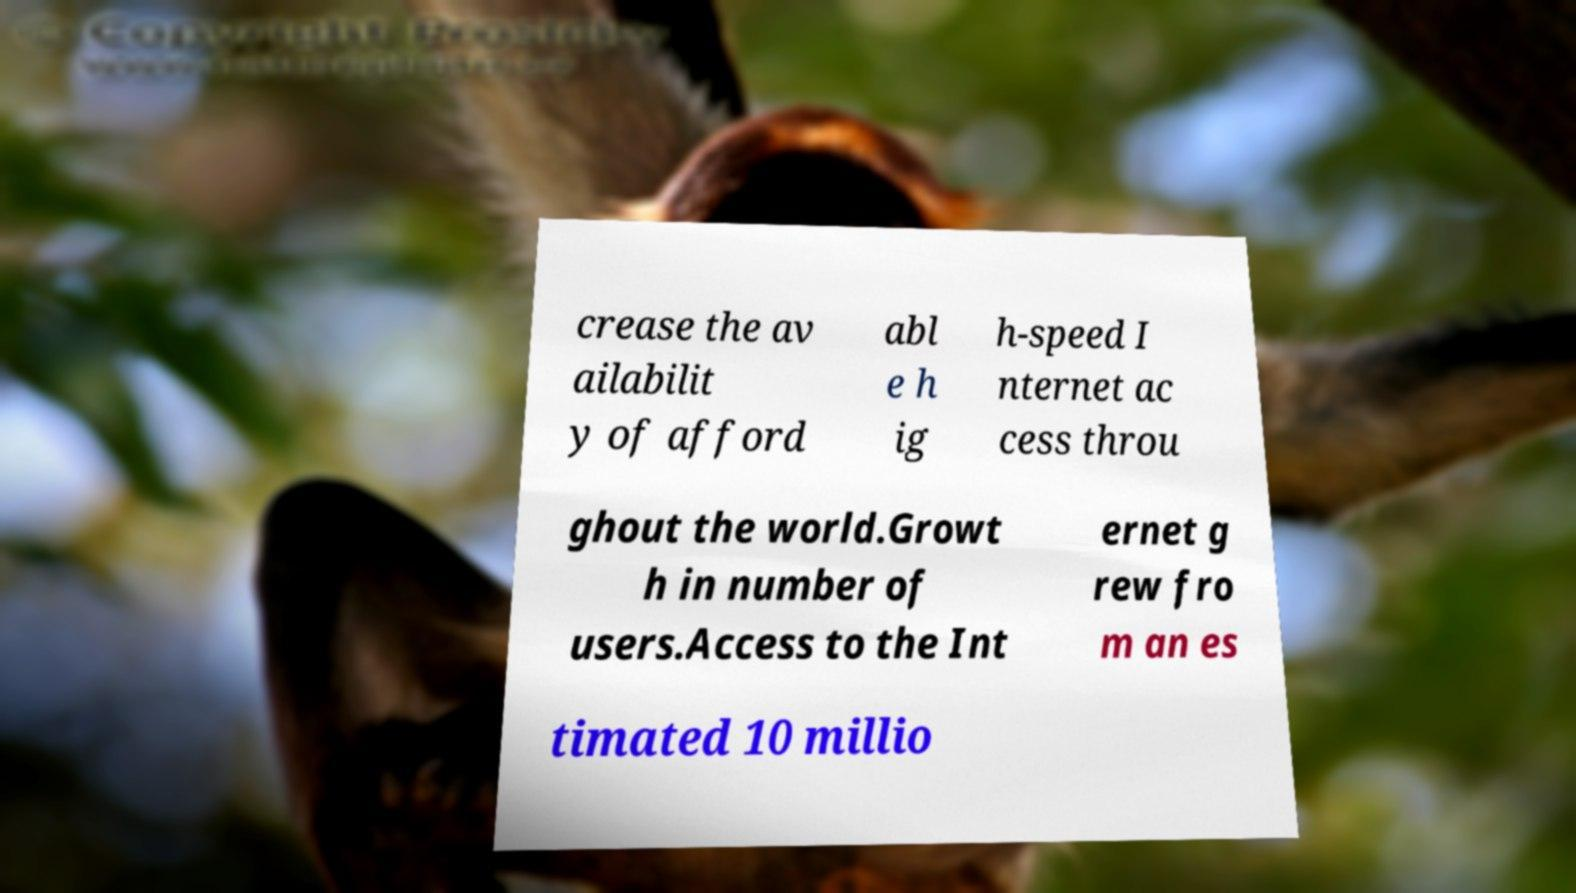Please read and relay the text visible in this image. What does it say? crease the av ailabilit y of afford abl e h ig h-speed I nternet ac cess throu ghout the world.Growt h in number of users.Access to the Int ernet g rew fro m an es timated 10 millio 